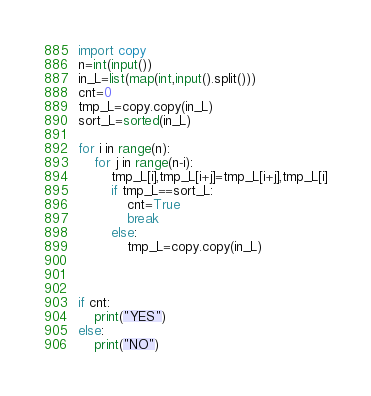<code> <loc_0><loc_0><loc_500><loc_500><_Python_>import copy
n=int(input())
in_L=list(map(int,input().split()))
cnt=0
tmp_L=copy.copy(in_L)
sort_L=sorted(in_L)

for i in range(n):
    for j in range(n-i):
        tmp_L[i],tmp_L[i+j]=tmp_L[i+j],tmp_L[i]
        if tmp_L==sort_L:
            cnt=True
            break
        else:
            tmp_L=copy.copy(in_L)
            
            
        
if cnt:
    print("YES")
else:
    print("NO")</code> 